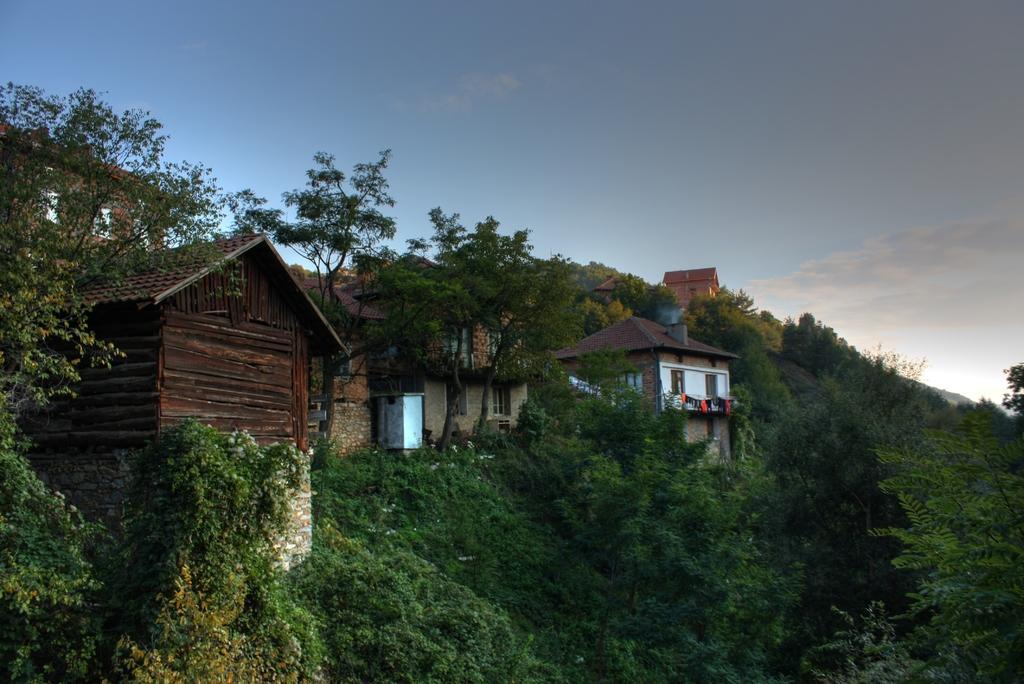In one or two sentences, can you explain what this image depicts? In the image we can see there are buildings, trees and the sky. 